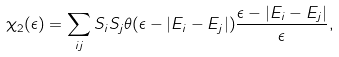Convert formula to latex. <formula><loc_0><loc_0><loc_500><loc_500>\chi _ { 2 } ( \epsilon ) = \sum _ { i j } S _ { i } S _ { j } \theta ( \epsilon - | E _ { i } - E _ { j } | ) \frac { \epsilon - | E _ { i } - E _ { j } | } { \epsilon } ,</formula> 